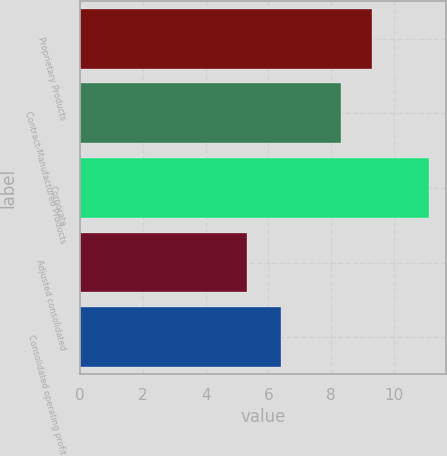Convert chart. <chart><loc_0><loc_0><loc_500><loc_500><bar_chart><fcel>Proprietary Products<fcel>Contract-Manufactured Products<fcel>Corporate<fcel>Adjusted consolidated<fcel>Consolidated operating profit<nl><fcel>9.3<fcel>8.3<fcel>11.1<fcel>5.3<fcel>6.4<nl></chart> 